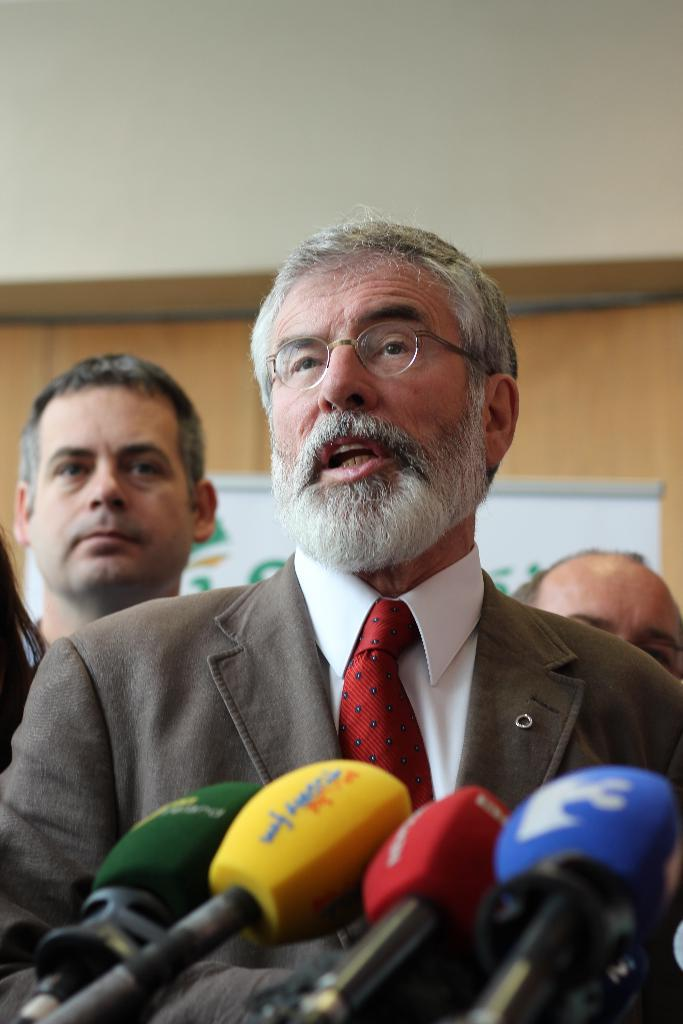What objects are present in the image that are used for amplifying sound? There are microphones in the image. What else can be seen in the image besides microphones? There are people in the image. What can be seen in the background of the image? There is a board and a wall in the background of the image. How many trucks are parked next to the wall in the image? There are no trucks present in the image; it only features microphones, people, a board, and a wall. 